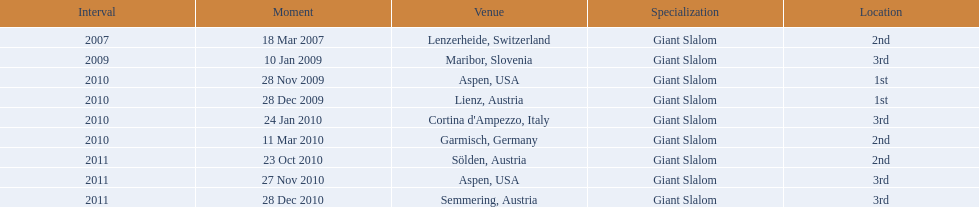What is the total number of her 2nd place finishes on the list? 3. 